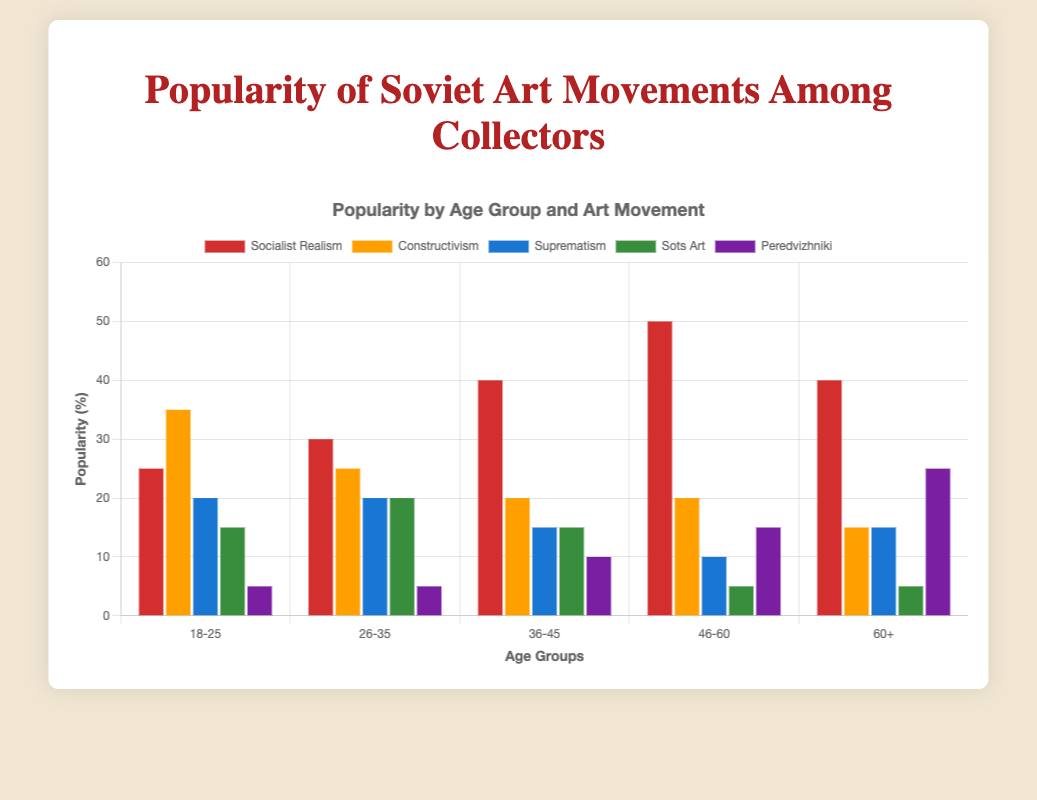Which age group shows the highest popularity for Socialist Realism? Look at the "Socialist Realism" bars on the graph and find the one with the highest height. It appears that the 46-60 age group has the highest bar in this category, indicating the highest popularity.
Answer: 46-60 Compare the popularity of Constructivism between age groups 18-25 and 60+. Which is more popular? Identify the bars for Constructivism within the two age groups. The popularity for 18-25 is 35%, whereas for 60+ it is 15%. Thus, Constructivism is more popular among the 18-25 age group.
Answer: 18-25 Which age group shows the least interest in Peredvizhniki? Look at the "Peredvizhniki" bars for each age group and find the one with the shortest height. Both the 18-25 and 26-35 age groups have bars with a value of 5%, which is the minimum.
Answer: 18-25 and 26-35 How much more popular is Sots Art among the 26-35 age group compared to the 60+ age group? Check the heights of the Sots Art bars for both age groups. For 26-35, the popularity is 20%, and for 60+ it is 5%. Subtract the smaller value from the larger one: 20% - 5% = 15%.
Answer: 15% Which art movement is more popular among the 36-45 age group, Socialist Realism or Suprematism? Look at the corresponding bars for the age group 36-45. The popularity of Socialist Realism is 40%, and that of Suprematism is 15%. Therefore, Socialist Realism is more popular.
Answer: Socialist Realism What is the average popularity of Constructivism across all age groups? Sum up the popularity for Constructivism across all age groups (35 + 25 + 20 + 20 + 15 = 115). There are 5 age groups, so divide by 5: 115/5 = 23%.
Answer: 23% What is the difference in popularity of Socialist Realism between the 26-35 and 46-60 age groups? The popularity for Socialist Realism in the 26-35 age group is 30%, and for the 46-60 age group, it is 50%. Subtract the smaller value from the larger one: 50% - 30% = 20%.
Answer: 20% What is the total popularity percentage of Suprematism in the 26-35 and 36-45 age groups combined? Add the popularity values for Suprematism in these age groups: 20% (26-35) + 15% (36-45) = 35%.
Answer: 35% Which age group has the highest diversity in preferences, i.e., the smallest difference between the most and least popular movements? Look at the popularity ranges for each age group and calculate the difference between the highest and lowest values. For the 18-25 age group, the values are 35% (highest) - 5% (lowest) = 30%. For 26-35, it’s 30% - 5% = 25%. For 36-45, it’s 40% - 10% = 30%. For 46-60, it’s 50% - 5% = 45%. For 60+, it’s 40% - 5% = 35%. The 26-35 age group shows the smallest difference, indicating the highest diversity in preferences.
Answer: 26-35 Between 18-25 and 26-35 age groups, which has a higher combined popularity for Socialist Realism and Sots Art? Sum the popularity values for Socialist Realism and Sots Art in each age group. For 18-25: 25% + 15% = 40%. For 26-35: 30% + 20% = 50%.
Answer: 26-35 